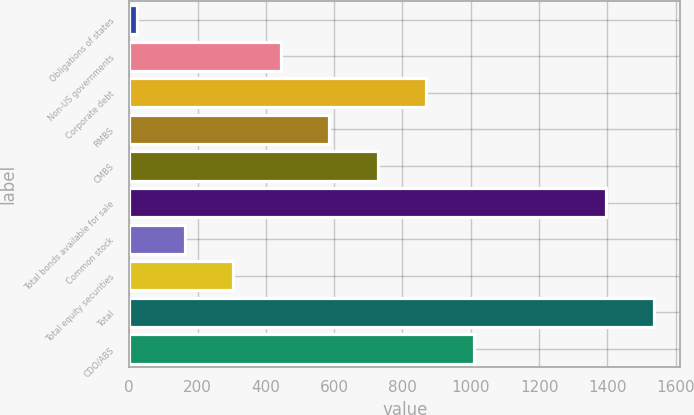Convert chart to OTSL. <chart><loc_0><loc_0><loc_500><loc_500><bar_chart><fcel>Obligations of states<fcel>Non-US governments<fcel>Corporate debt<fcel>RMBS<fcel>CMBS<fcel>Total bonds available for sale<fcel>Common stock<fcel>Total equity securities<fcel>Total<fcel>CDO/ABS<nl><fcel>22<fcel>445.3<fcel>868.6<fcel>586.4<fcel>727.5<fcel>1396<fcel>163.1<fcel>304.2<fcel>1537.1<fcel>1009.7<nl></chart> 